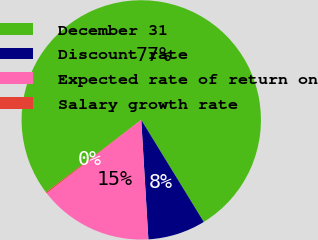Convert chart. <chart><loc_0><loc_0><loc_500><loc_500><pie_chart><fcel>December 31<fcel>Discount rate<fcel>Expected rate of return on<fcel>Salary growth rate<nl><fcel>76.59%<fcel>7.8%<fcel>15.45%<fcel>0.16%<nl></chart> 